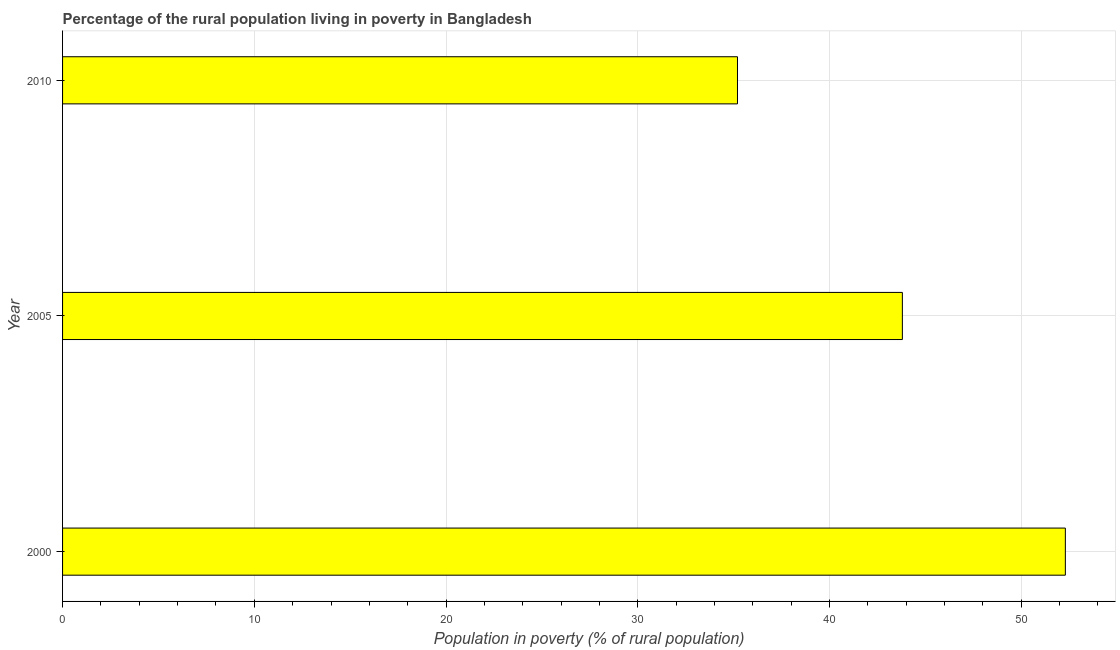Does the graph contain grids?
Offer a very short reply. Yes. What is the title of the graph?
Give a very brief answer. Percentage of the rural population living in poverty in Bangladesh. What is the label or title of the X-axis?
Give a very brief answer. Population in poverty (% of rural population). What is the percentage of rural population living below poverty line in 2010?
Your answer should be very brief. 35.2. Across all years, what is the maximum percentage of rural population living below poverty line?
Provide a succinct answer. 52.3. Across all years, what is the minimum percentage of rural population living below poverty line?
Offer a terse response. 35.2. In which year was the percentage of rural population living below poverty line minimum?
Offer a terse response. 2010. What is the sum of the percentage of rural population living below poverty line?
Keep it short and to the point. 131.3. What is the difference between the percentage of rural population living below poverty line in 2000 and 2005?
Ensure brevity in your answer.  8.5. What is the average percentage of rural population living below poverty line per year?
Your answer should be compact. 43.77. What is the median percentage of rural population living below poverty line?
Give a very brief answer. 43.8. Do a majority of the years between 2000 and 2005 (inclusive) have percentage of rural population living below poverty line greater than 52 %?
Your answer should be very brief. No. What is the ratio of the percentage of rural population living below poverty line in 2000 to that in 2010?
Make the answer very short. 1.49. Is the percentage of rural population living below poverty line in 2000 less than that in 2005?
Your answer should be very brief. No. Is the difference between the percentage of rural population living below poverty line in 2000 and 2005 greater than the difference between any two years?
Make the answer very short. No. What is the difference between the highest and the lowest percentage of rural population living below poverty line?
Your response must be concise. 17.1. What is the Population in poverty (% of rural population) in 2000?
Your response must be concise. 52.3. What is the Population in poverty (% of rural population) in 2005?
Make the answer very short. 43.8. What is the Population in poverty (% of rural population) in 2010?
Offer a terse response. 35.2. What is the ratio of the Population in poverty (% of rural population) in 2000 to that in 2005?
Provide a short and direct response. 1.19. What is the ratio of the Population in poverty (% of rural population) in 2000 to that in 2010?
Provide a succinct answer. 1.49. What is the ratio of the Population in poverty (% of rural population) in 2005 to that in 2010?
Make the answer very short. 1.24. 